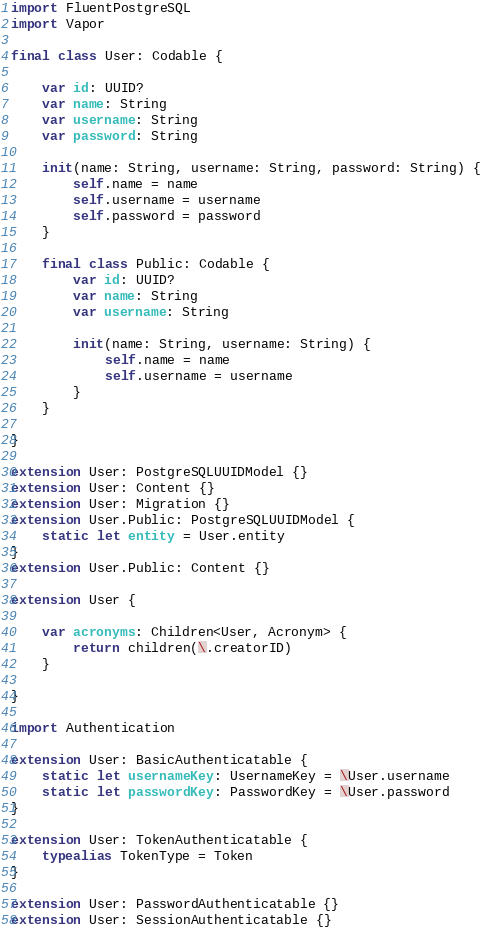<code> <loc_0><loc_0><loc_500><loc_500><_Swift_>import FluentPostgreSQL
import Vapor

final class User: Codable {
    
    var id: UUID?
    var name: String
    var username: String
    var password: String
    
    init(name: String, username: String, password: String) {
        self.name = name
        self.username = username
        self.password = password
    }
    
    final class Public: Codable {
        var id: UUID?
        var name: String
        var username: String
        
        init(name: String, username: String) {
            self.name = name
            self.username = username
        }
    }
    
}

extension User: PostgreSQLUUIDModel {}
extension User: Content {}
extension User: Migration {}
extension User.Public: PostgreSQLUUIDModel {
    static let entity = User.entity
}
extension User.Public: Content {}

extension User {
    
    var acronyms: Children<User, Acronym> {
        return children(\.creatorID)
    }
    
}

import Authentication

extension User: BasicAuthenticatable {
    static let usernameKey: UsernameKey = \User.username
    static let passwordKey: PasswordKey = \User.password
}

extension User: TokenAuthenticatable {
    typealias TokenType = Token
}

extension User: PasswordAuthenticatable {}
extension User: SessionAuthenticatable {}
</code> 